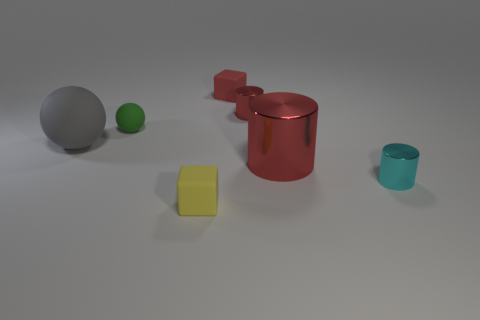Add 3 big cyan metal cylinders. How many objects exist? 10 Subtract all spheres. How many objects are left? 5 Add 7 big red cylinders. How many big red cylinders are left? 8 Add 6 big purple matte balls. How many big purple matte balls exist? 6 Subtract 1 yellow blocks. How many objects are left? 6 Subtract all big purple things. Subtract all big rubber objects. How many objects are left? 6 